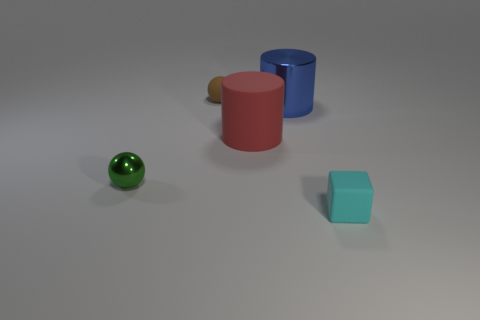Subtract all spheres. How many objects are left? 3 Subtract all red balls. Subtract all brown blocks. How many balls are left? 2 Subtract all gray cylinders. How many brown spheres are left? 1 Subtract all big brown shiny spheres. Subtract all tiny green balls. How many objects are left? 4 Add 4 metallic things. How many metallic things are left? 6 Add 4 spheres. How many spheres exist? 6 Add 5 rubber objects. How many objects exist? 10 Subtract 0 purple cylinders. How many objects are left? 5 Subtract 1 blocks. How many blocks are left? 0 